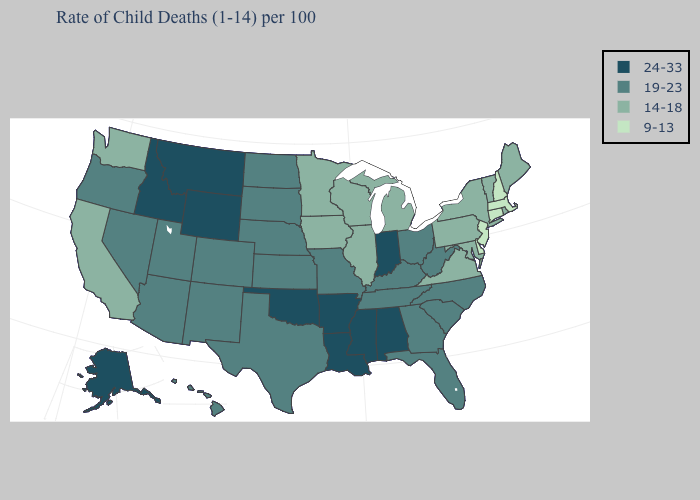Name the states that have a value in the range 9-13?
Write a very short answer. Connecticut, Delaware, Massachusetts, New Hampshire, New Jersey. Which states hav the highest value in the West?
Short answer required. Alaska, Idaho, Montana, Wyoming. Among the states that border North Dakota , which have the highest value?
Be succinct. Montana. What is the value of Indiana?
Give a very brief answer. 24-33. What is the value of Missouri?
Concise answer only. 19-23. What is the highest value in states that border Oklahoma?
Be succinct. 24-33. What is the value of Texas?
Answer briefly. 19-23. Among the states that border Maryland , which have the highest value?
Keep it brief. West Virginia. Name the states that have a value in the range 14-18?
Be succinct. California, Illinois, Iowa, Maine, Maryland, Michigan, Minnesota, New York, Pennsylvania, Rhode Island, Vermont, Virginia, Washington, Wisconsin. Does Delaware have the lowest value in the South?
Be succinct. Yes. Name the states that have a value in the range 9-13?
Answer briefly. Connecticut, Delaware, Massachusetts, New Hampshire, New Jersey. Does the first symbol in the legend represent the smallest category?
Quick response, please. No. Does Kentucky have the same value as Washington?
Keep it brief. No. Does New Mexico have a higher value than New Hampshire?
Quick response, please. Yes. What is the highest value in states that border Texas?
Concise answer only. 24-33. 